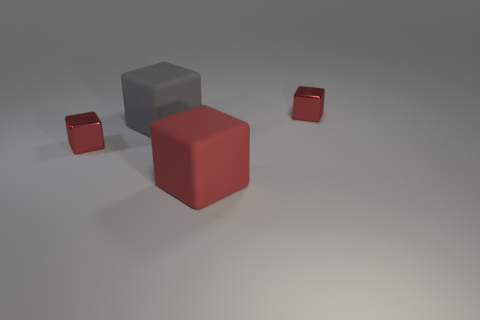What is the material of the gray cube that is the same size as the red rubber block?
Give a very brief answer. Rubber. Do the matte object behind the big red cube and the red matte thing have the same shape?
Your response must be concise. Yes. Are there more gray things that are behind the big red thing than red objects behind the large gray thing?
Provide a succinct answer. No. How many big red things are the same material as the large gray thing?
Offer a terse response. 1. Does the gray object have the same size as the red rubber cube?
Keep it short and to the point. Yes. What number of things are large brown metal balls or big red matte blocks?
Ensure brevity in your answer.  1. Are there any large purple things that have the same shape as the gray thing?
Provide a short and direct response. No. The small object behind the metal cube that is left of the big red matte thing is what shape?
Keep it short and to the point. Cube. Are there any cyan metal cylinders that have the same size as the gray object?
Keep it short and to the point. No. Is the number of large green spheres less than the number of rubber cubes?
Ensure brevity in your answer.  Yes. 